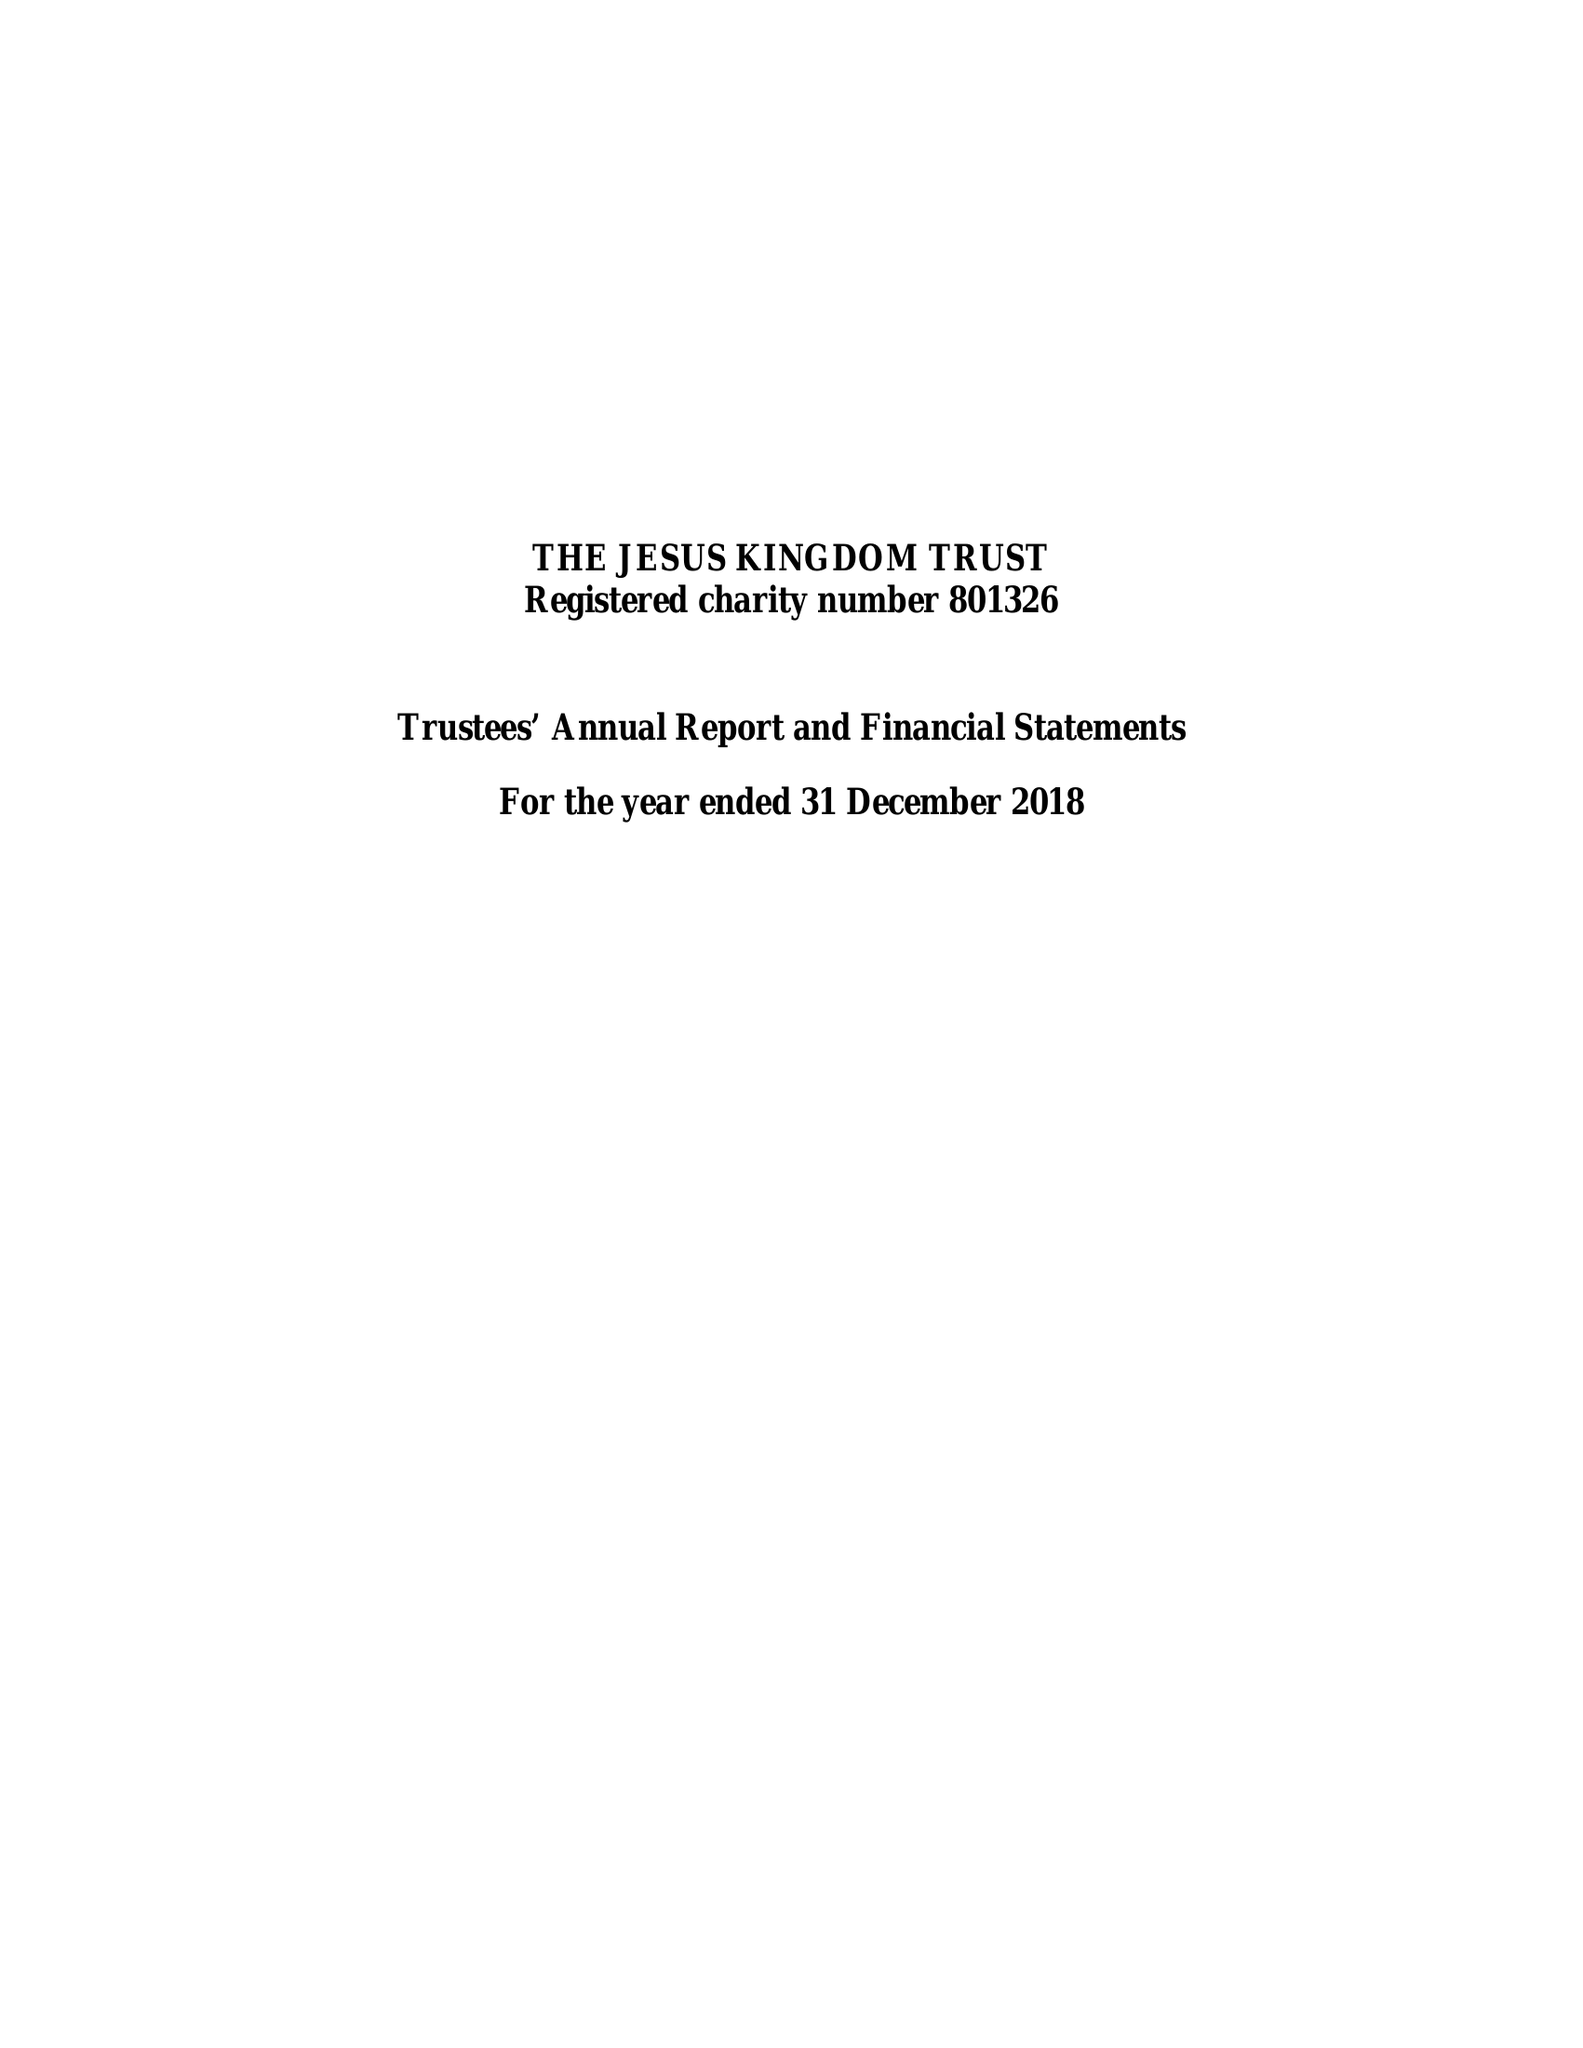What is the value for the address__postcode?
Answer the question using a single word or phrase. N12 8QJ 